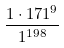Convert formula to latex. <formula><loc_0><loc_0><loc_500><loc_500>\frac { 1 \cdot 1 7 1 ^ { 9 } } { 1 ^ { 1 9 8 } }</formula> 